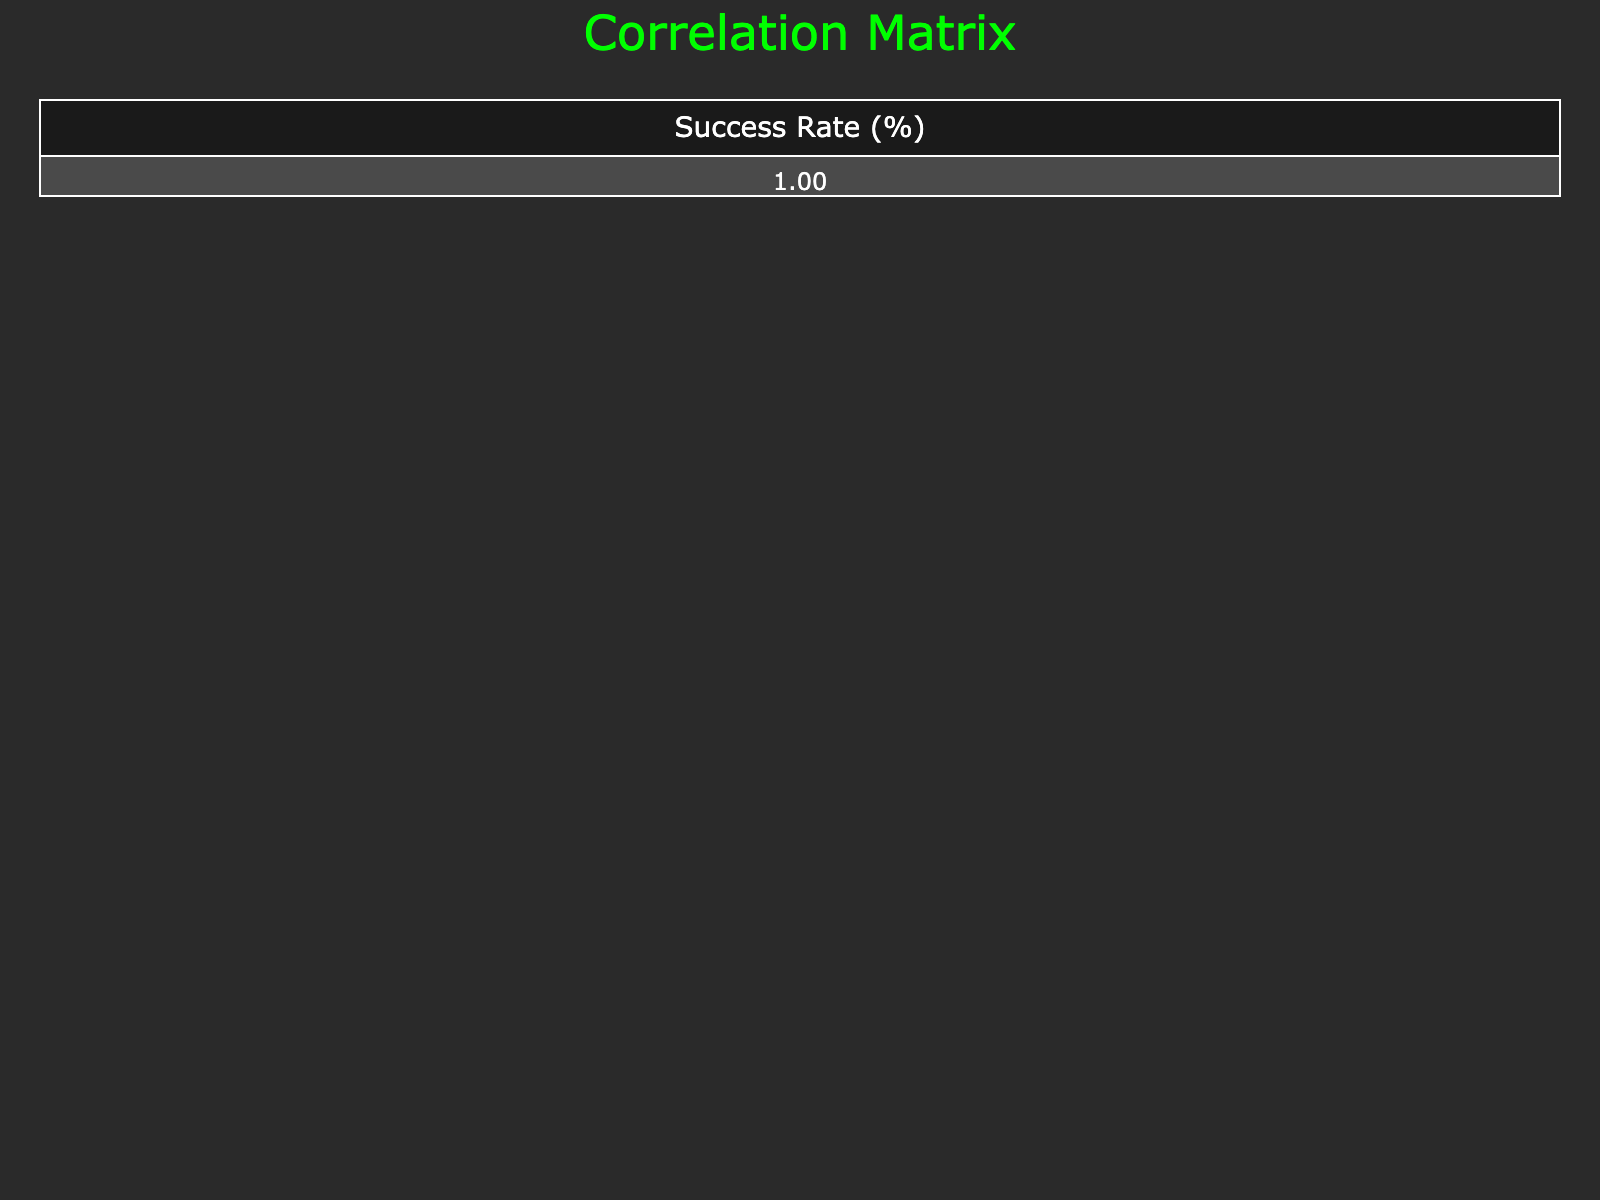What is the success rate for an Advanced hacker in DDoS Attack? According to the table, the success rate for the Advanced skill level in a DDoS Attack is listed as 70%.
Answer: 70% What is the skill level of the hacker with the highest success rate? The table shows that the Expert skill level has the highest success rate at 90% for SQL Injection.
Answer: Expert What is the average success rate for Intermediate hackers across all attack types? There are three success rates for Intermediate hackers: 45%, 40%, and 50%. The sum is 45 + 40 + 50 = 135. The average is 135/3 = 45.
Answer: 45 Is the success rate for Beginners higher in Phishing or Social Engineering? The success rate for Beginners is 15% in Phishing and 10% in Social Engineering. Comparing these, 15% is higher than 10%.
Answer: Yes What is the difference in success rates between Advanced hackers in Credential Stuffing and Cross-Site Scripting? The success rates are 65% for Credential Stuffing and 75% for Cross-Site Scripting. The difference is 75 - 65 = 10%.
Answer: 10% What is the overall lowest success rate recorded in the table? The table indicates that the lowest success rate is 10%, which is associated with Beginners in Social Engineering.
Answer: 10% Is it true that all Expert skill-level hackers have a lower success rate than 85%? The table shows two Expert instances: 90% for SQL Injection and 85% for Zero-Day Exploit. Since one instance exceeds 85%, the statement is false.
Answer: No What skills categorize hackers with a success rate above 70%? The table shows that only Advanced (DDoS Attack and Cross-Site Scripting) and Expert hackers (SQL Injection and Zero-Day Exploit) have success rates of 70% and above.
Answer: Advanced and Expert 